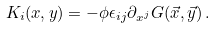<formula> <loc_0><loc_0><loc_500><loc_500>K _ { i } ( x , y ) = - \phi \epsilon _ { i j } \partial _ { x ^ { j } } G ( \vec { x } , \vec { y } ) \, .</formula> 